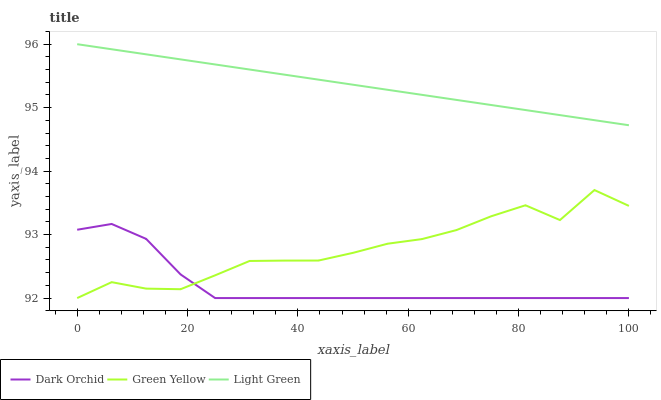Does Light Green have the minimum area under the curve?
Answer yes or no. No. Does Dark Orchid have the maximum area under the curve?
Answer yes or no. No. Is Dark Orchid the smoothest?
Answer yes or no. No. Is Dark Orchid the roughest?
Answer yes or no. No. Does Light Green have the lowest value?
Answer yes or no. No. Does Dark Orchid have the highest value?
Answer yes or no. No. Is Green Yellow less than Light Green?
Answer yes or no. Yes. Is Light Green greater than Green Yellow?
Answer yes or no. Yes. Does Green Yellow intersect Light Green?
Answer yes or no. No. 